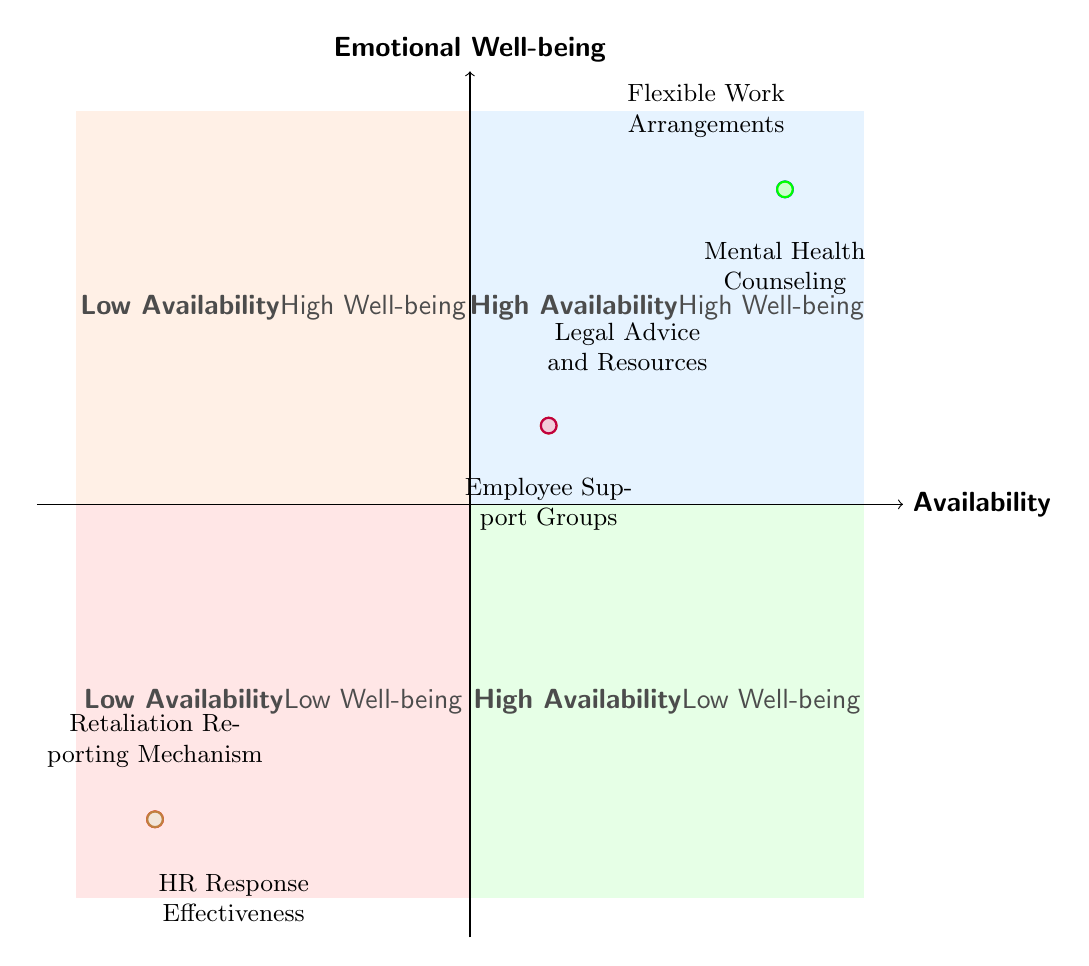What is placed in the high availability and high emotional well-being quadrant? By examining the diagram, we see that the high availability and high emotional well-being quadrant (top right) contains the nodes representing "Mental Health Counseling" and "Flexible Work Arrangements." Both services are critical for employee support.
Answer: Mental Health Counseling, Flexible Work Arrangements How many support systems have low emotional well-being? The quadrants show that there are two support systems placed in the low emotional well-being quadrant (bottom left), specifically the "Retaliation Reporting Mechanism" and "HR Response Effectiveness."
Answer: 2 Which support systems are marked under moderate availability? To find the support systems under moderate availability, we refer to the x-axis of the diagram. There are two systems located in the moderate availability quadrant, which are "Employee Support Groups" and "Legal Advice and Resources."
Answer: Employee Support Groups, Legal Advice and Resources What is the emotional well-being level for HR Response Effectiveness? HR Response Effectiveness is located in the bottom left quadrant, which is labeled as "Low Emotional Well-being." This means it directly represents a poor emotional support scenario for employees.
Answer: Low Emotional Well-being Which quadrant contains the Employee Support Groups? The Employee Support Groups are present in the quadrant labeled with "Moderate Availability" and "Moderate Emotional Well-being." This indicates that their impact on both availability and emotional well-being is neither high nor low.
Answer: Moderate Availability, Moderate Emotional Well-being What is the relationship between Mental Health Counseling and Flexible Work Arrangements? Both nodes are positioned in the quadrant that indicates "High Availability" and "High Emotional Well-being." This suggests they both contribute positively towards emotional well-being for employees and are readily available support systems.
Answer: High Availability, High Emotional Well-being 